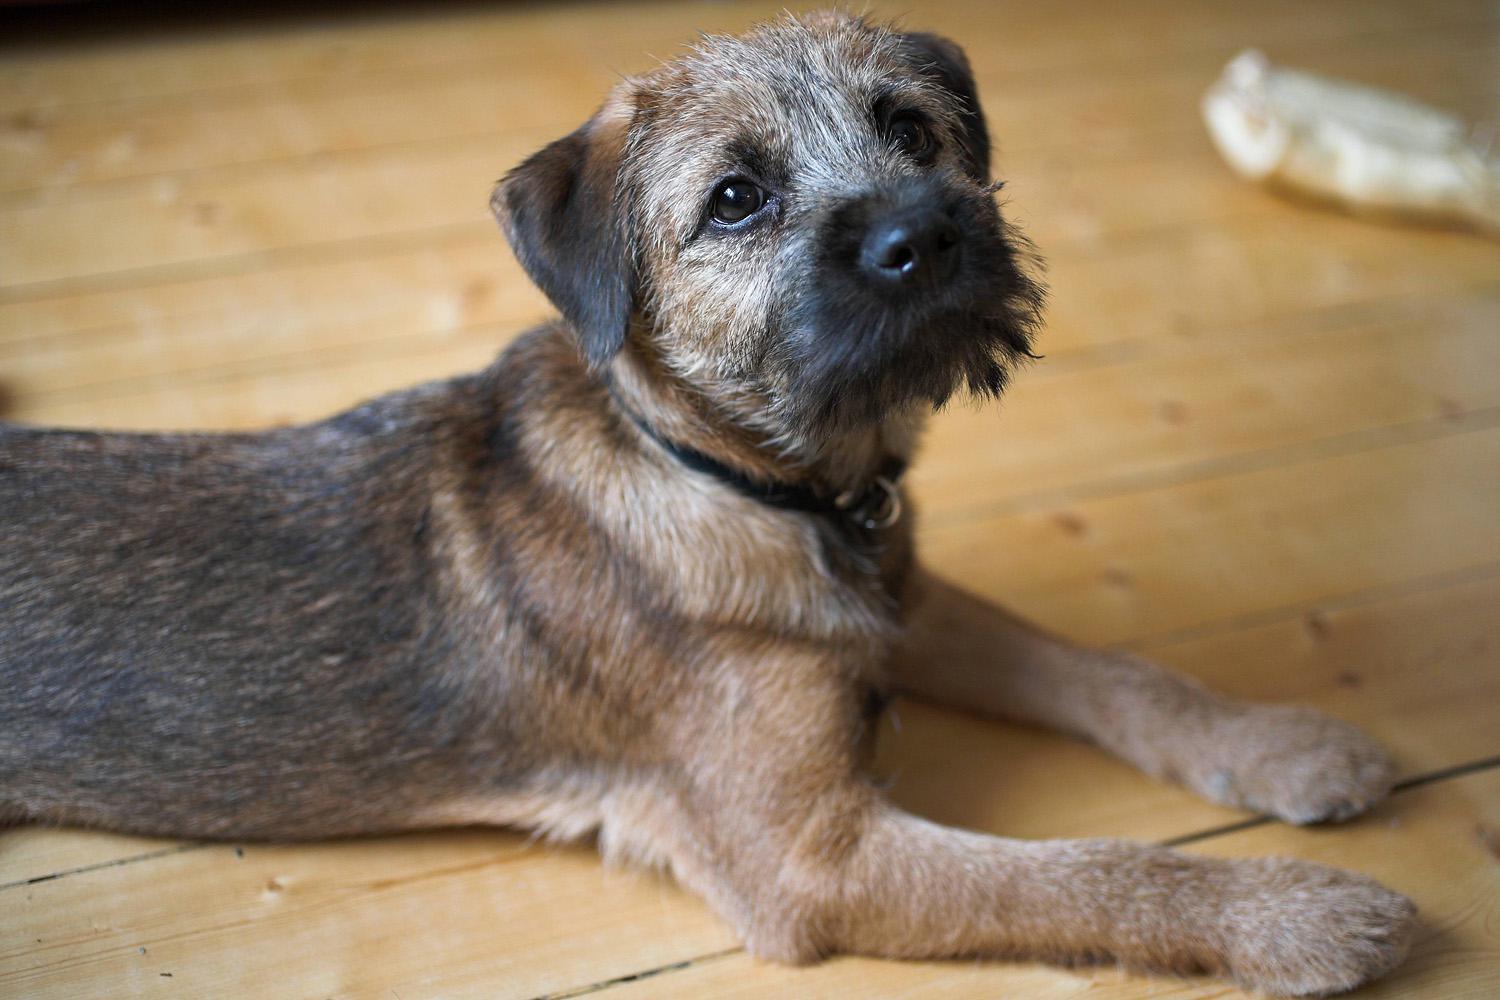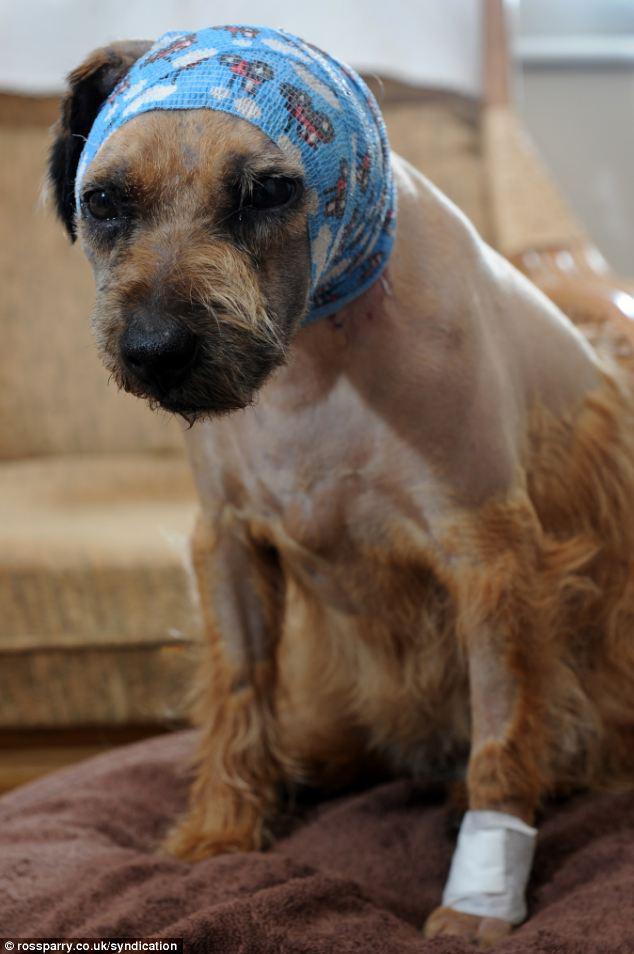The first image is the image on the left, the second image is the image on the right. Considering the images on both sides, is "The dogs are inside." valid? Answer yes or no. Yes. The first image is the image on the left, the second image is the image on the right. Evaluate the accuracy of this statement regarding the images: "There are two dogs total outside in the grass.". Is it true? Answer yes or no. No. 